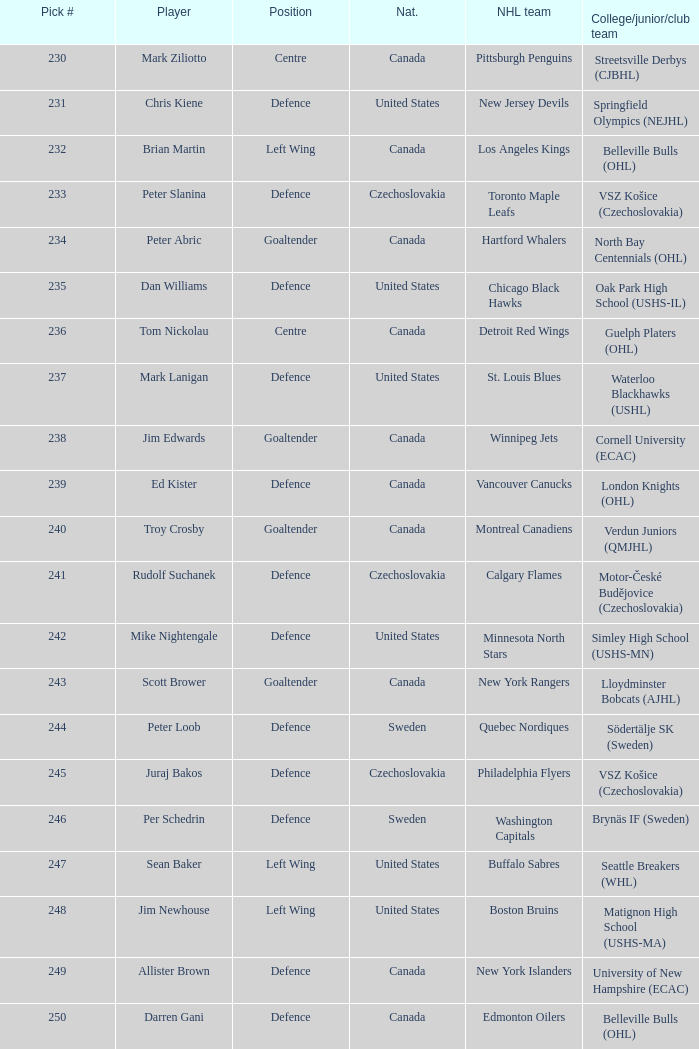Give me the full table as a dictionary. {'header': ['Pick #', 'Player', 'Position', 'Nat.', 'NHL team', 'College/junior/club team'], 'rows': [['230', 'Mark Ziliotto', 'Centre', 'Canada', 'Pittsburgh Penguins', 'Streetsville Derbys (CJBHL)'], ['231', 'Chris Kiene', 'Defence', 'United States', 'New Jersey Devils', 'Springfield Olympics (NEJHL)'], ['232', 'Brian Martin', 'Left Wing', 'Canada', 'Los Angeles Kings', 'Belleville Bulls (OHL)'], ['233', 'Peter Slanina', 'Defence', 'Czechoslovakia', 'Toronto Maple Leafs', 'VSZ Košice (Czechoslovakia)'], ['234', 'Peter Abric', 'Goaltender', 'Canada', 'Hartford Whalers', 'North Bay Centennials (OHL)'], ['235', 'Dan Williams', 'Defence', 'United States', 'Chicago Black Hawks', 'Oak Park High School (USHS-IL)'], ['236', 'Tom Nickolau', 'Centre', 'Canada', 'Detroit Red Wings', 'Guelph Platers (OHL)'], ['237', 'Mark Lanigan', 'Defence', 'United States', 'St. Louis Blues', 'Waterloo Blackhawks (USHL)'], ['238', 'Jim Edwards', 'Goaltender', 'Canada', 'Winnipeg Jets', 'Cornell University (ECAC)'], ['239', 'Ed Kister', 'Defence', 'Canada', 'Vancouver Canucks', 'London Knights (OHL)'], ['240', 'Troy Crosby', 'Goaltender', 'Canada', 'Montreal Canadiens', 'Verdun Juniors (QMJHL)'], ['241', 'Rudolf Suchanek', 'Defence', 'Czechoslovakia', 'Calgary Flames', 'Motor-České Budějovice (Czechoslovakia)'], ['242', 'Mike Nightengale', 'Defence', 'United States', 'Minnesota North Stars', 'Simley High School (USHS-MN)'], ['243', 'Scott Brower', 'Goaltender', 'Canada', 'New York Rangers', 'Lloydminster Bobcats (AJHL)'], ['244', 'Peter Loob', 'Defence', 'Sweden', 'Quebec Nordiques', 'Södertälje SK (Sweden)'], ['245', 'Juraj Bakos', 'Defence', 'Czechoslovakia', 'Philadelphia Flyers', 'VSZ Košice (Czechoslovakia)'], ['246', 'Per Schedrin', 'Defence', 'Sweden', 'Washington Capitals', 'Brynäs IF (Sweden)'], ['247', 'Sean Baker', 'Left Wing', 'United States', 'Buffalo Sabres', 'Seattle Breakers (WHL)'], ['248', 'Jim Newhouse', 'Left Wing', 'United States', 'Boston Bruins', 'Matignon High School (USHS-MA)'], ['249', 'Allister Brown', 'Defence', 'Canada', 'New York Islanders', 'University of New Hampshire (ECAC)'], ['250', 'Darren Gani', 'Defence', 'Canada', 'Edmonton Oilers', 'Belleville Bulls (OHL)']]} To which organziation does the  winnipeg jets belong to? Cornell University (ECAC). 